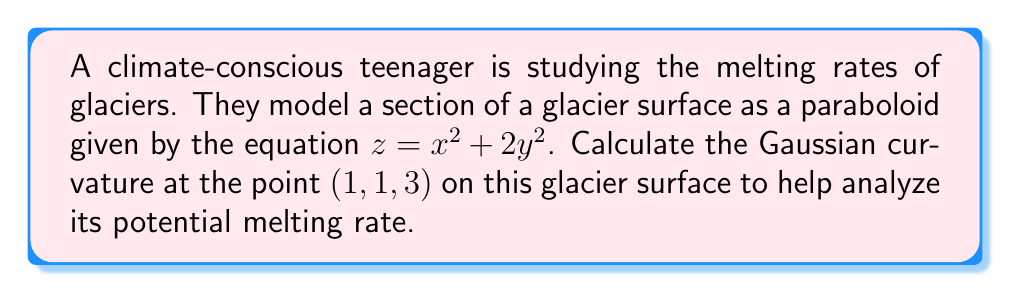Help me with this question. To compute the Gaussian curvature of the glacier surface, we'll follow these steps:

1) The surface is given by $z = x^2 + 2y^2$. We need to find the partial derivatives:

   $z_x = 2x$
   $z_y = 4y$
   $z_{xx} = 2$
   $z_{xy} = 0$
   $z_{yy} = 4$

2) The Gaussian curvature K is given by the formula:

   $$K = \frac{z_{xx}z_{yy} - z_{xy}^2}{(1 + z_x^2 + z_y^2)^2}$$

3) At the point (1, 1, 3), we have:

   $z_x = 2(1) = 2$
   $z_y = 4(1) = 4$
   $z_{xx} = 2$
   $z_{xy} = 0$
   $z_{yy} = 4$

4) Substituting these values into the formula:

   $$K = \frac{(2)(4) - 0^2}{(1 + 2^2 + 4^2)^2}$$

5) Simplify:

   $$K = \frac{8}{(1 + 4 + 16)^2} = \frac{8}{21^2} = \frac{8}{441}$$

6) This positive Gaussian curvature indicates that the surface is locally elliptic at this point, which could affect the melting rate of the glacier.
Answer: $\frac{8}{441}$ 